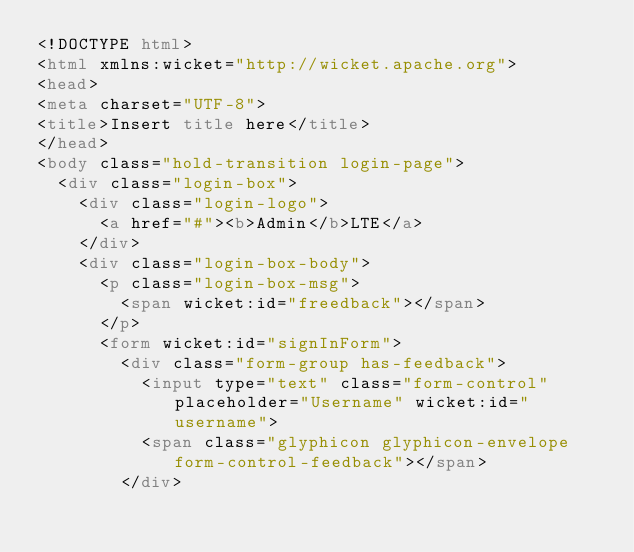Convert code to text. <code><loc_0><loc_0><loc_500><loc_500><_HTML_><!DOCTYPE html>
<html xmlns:wicket="http://wicket.apache.org">
<head>
<meta charset="UTF-8">
<title>Insert title here</title>
</head>
<body class="hold-transition login-page">
	<div class="login-box">
		<div class="login-logo">
			<a href="#"><b>Admin</b>LTE</a>
		</div>
		<div class="login-box-body">
			<p class="login-box-msg">
				<span wicket:id="freedback"></span>
			</p>
			<form wicket:id="signInForm">
				<div class="form-group has-feedback">
					<input type="text" class="form-control" placeholder="Username" wicket:id="username">
					<span class="glyphicon glyphicon-envelope form-control-feedback"></span>
				</div></code> 